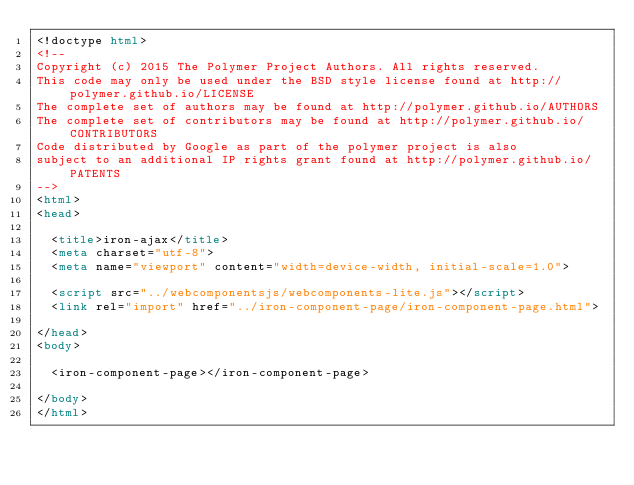Convert code to text. <code><loc_0><loc_0><loc_500><loc_500><_HTML_><!doctype html>
<!--
Copyright (c) 2015 The Polymer Project Authors. All rights reserved.
This code may only be used under the BSD style license found at http://polymer.github.io/LICENSE
The complete set of authors may be found at http://polymer.github.io/AUTHORS
The complete set of contributors may be found at http://polymer.github.io/CONTRIBUTORS
Code distributed by Google as part of the polymer project is also
subject to an additional IP rights grant found at http://polymer.github.io/PATENTS
-->
<html>
<head>

  <title>iron-ajax</title>
  <meta charset="utf-8">
  <meta name="viewport" content="width=device-width, initial-scale=1.0">

  <script src="../webcomponentsjs/webcomponents-lite.js"></script>
  <link rel="import" href="../iron-component-page/iron-component-page.html">

</head>
<body>

  <iron-component-page></iron-component-page>

</body>
</html>
</code> 